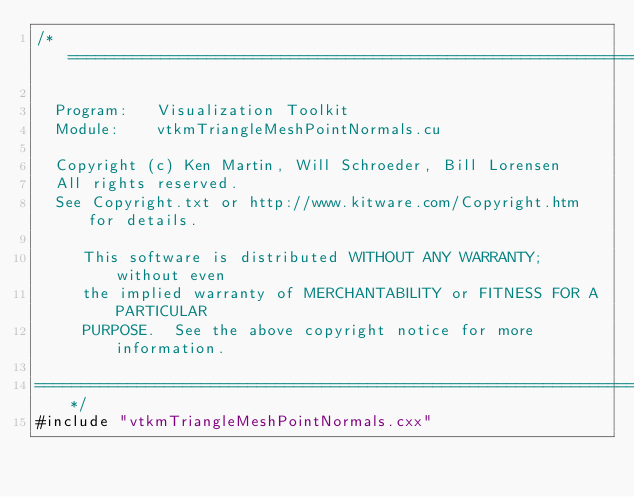Convert code to text. <code><loc_0><loc_0><loc_500><loc_500><_Cuda_>/*=========================================================================

  Program:   Visualization Toolkit
  Module:    vtkmTriangleMeshPointNormals.cu

  Copyright (c) Ken Martin, Will Schroeder, Bill Lorensen
  All rights reserved.
  See Copyright.txt or http://www.kitware.com/Copyright.htm for details.

     This software is distributed WITHOUT ANY WARRANTY; without even
     the implied warranty of MERCHANTABILITY or FITNESS FOR A PARTICULAR
     PURPOSE.  See the above copyright notice for more information.

=========================================================================*/
#include "vtkmTriangleMeshPointNormals.cxx"
</code> 